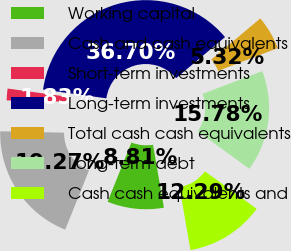<chart> <loc_0><loc_0><loc_500><loc_500><pie_chart><fcel>Working capital<fcel>Cash and cash equivalents<fcel>Short-term investments<fcel>Long-term investments<fcel>Total cash cash equivalents<fcel>Long-term debt<fcel>Cash cash equivalents and<nl><fcel>8.81%<fcel>19.27%<fcel>1.83%<fcel>36.7%<fcel>5.32%<fcel>15.78%<fcel>12.29%<nl></chart> 